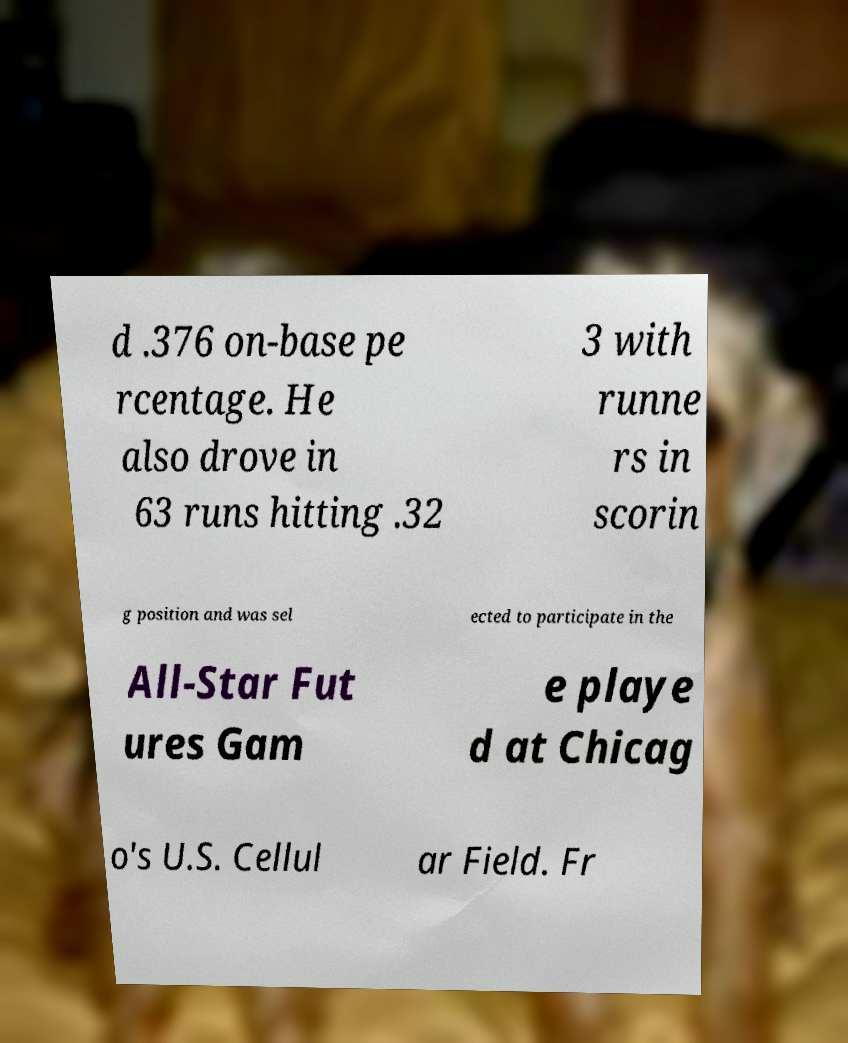Could you assist in decoding the text presented in this image and type it out clearly? d .376 on-base pe rcentage. He also drove in 63 runs hitting .32 3 with runne rs in scorin g position and was sel ected to participate in the All-Star Fut ures Gam e playe d at Chicag o's U.S. Cellul ar Field. Fr 